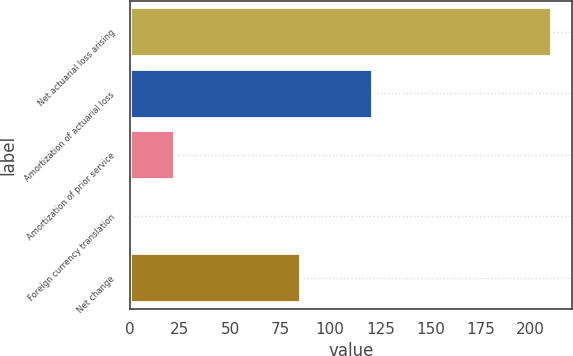Convert chart. <chart><loc_0><loc_0><loc_500><loc_500><bar_chart><fcel>Net actuarial loss arising<fcel>Amortization of actuarial loss<fcel>Amortization of prior service<fcel>Foreign currency translation<fcel>Net change<nl><fcel>210<fcel>121<fcel>21.9<fcel>1<fcel>85<nl></chart> 